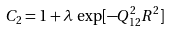Convert formula to latex. <formula><loc_0><loc_0><loc_500><loc_500>C _ { 2 } = 1 + \lambda \, \exp [ - Q _ { 1 2 } ^ { 2 } R ^ { 2 } ]</formula> 